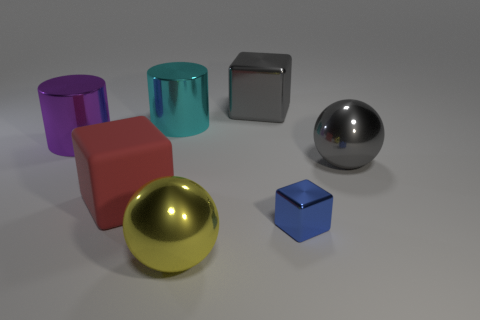Are there any yellow metallic balls that have the same size as the red block?
Your answer should be very brief. Yes. Are there fewer large gray objects that are on the left side of the tiny block than big brown metallic cylinders?
Give a very brief answer. No. Is the yellow thing the same size as the purple cylinder?
Make the answer very short. Yes. The blue thing that is the same material as the yellow object is what size?
Ensure brevity in your answer.  Small. What number of large balls have the same color as the large metal block?
Provide a short and direct response. 1. Are there fewer shiny spheres that are in front of the red matte cube than objects behind the yellow ball?
Make the answer very short. Yes. Do the metallic thing left of the matte cube and the large cyan metal thing have the same shape?
Offer a very short reply. Yes. Is there anything else that has the same material as the big red thing?
Your answer should be compact. No. Is the ball that is behind the yellow object made of the same material as the purple cylinder?
Offer a terse response. Yes. What material is the large cube in front of the gray object that is in front of the block that is behind the big gray shiny ball made of?
Keep it short and to the point. Rubber. 